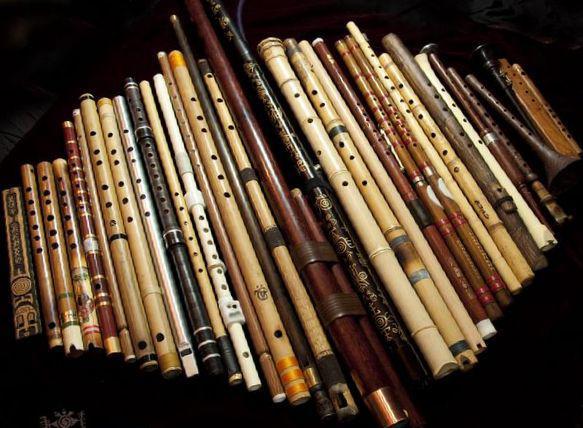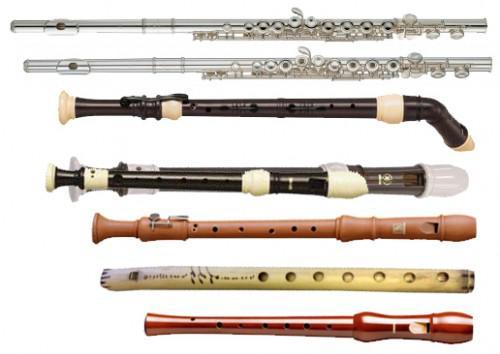The first image is the image on the left, the second image is the image on the right. Analyze the images presented: Is the assertion "The instrument in the image on the right has blue bands on it." valid? Answer yes or no. No. 